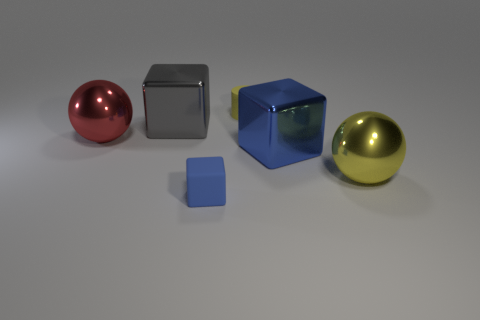What size is the cube that is to the left of the small cylinder and in front of the big gray shiny thing?
Make the answer very short. Small. Is there any other thing that is the same material as the big red object?
Your answer should be compact. Yes. Is the large red sphere made of the same material as the tiny thing behind the small cube?
Your answer should be compact. No. Are there fewer yellow metal spheres behind the yellow metal sphere than yellow metal things behind the tiny yellow rubber cylinder?
Make the answer very short. No. What is the small object that is behind the matte block made of?
Provide a succinct answer. Rubber. What is the color of the cube that is behind the yellow metal object and to the left of the large blue cube?
Offer a very short reply. Gray. What color is the big metallic thing behind the red metallic object?
Offer a terse response. Gray. Is there a brown rubber block that has the same size as the matte cylinder?
Keep it short and to the point. No. What is the material of the yellow sphere that is the same size as the gray metal thing?
Offer a terse response. Metal. How many things are big spheres to the left of the small blue matte thing or tiny matte objects behind the large red metal sphere?
Your response must be concise. 2. 